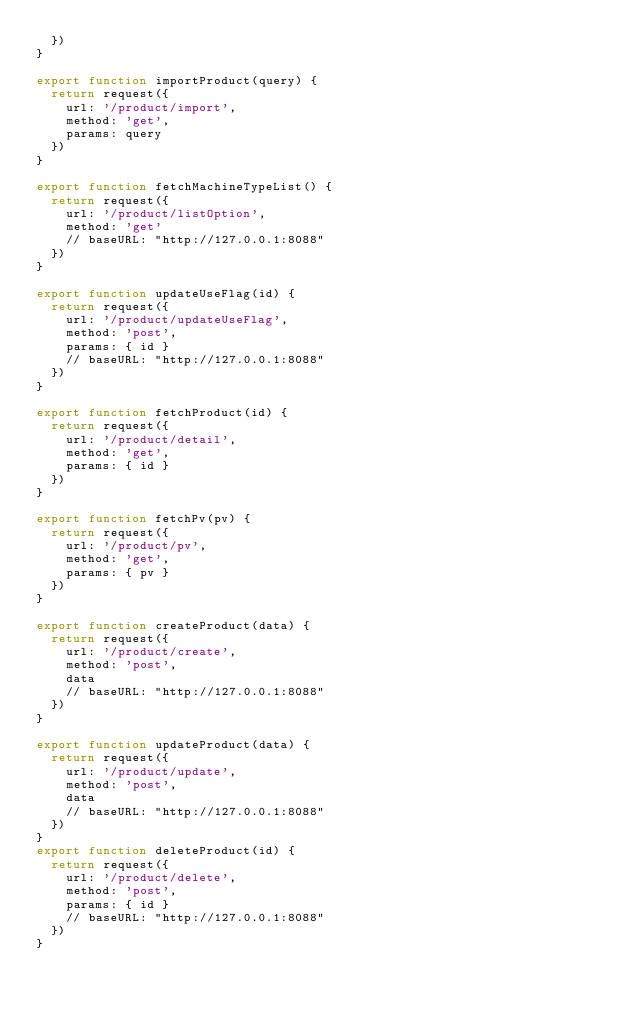<code> <loc_0><loc_0><loc_500><loc_500><_JavaScript_>  })
}

export function importProduct(query) {
  return request({
    url: '/product/import',
    method: 'get',
    params: query
  })
}

export function fetchMachineTypeList() {
  return request({
    url: '/product/listOption',
    method: 'get'
    // baseURL: "http://127.0.0.1:8088"
  })
}

export function updateUseFlag(id) {
  return request({
    url: '/product/updateUseFlag',
    method: 'post',
    params: { id }
    // baseURL: "http://127.0.0.1:8088"
  })
}

export function fetchProduct(id) {
  return request({
    url: '/product/detail',
    method: 'get',
    params: { id }
  })
}

export function fetchPv(pv) {
  return request({
    url: '/product/pv',
    method: 'get',
    params: { pv }
  })
}

export function createProduct(data) {
  return request({
    url: '/product/create',
    method: 'post',
    data
    // baseURL: "http://127.0.0.1:8088"
  })
}

export function updateProduct(data) {
  return request({
    url: '/product/update',
    method: 'post',
    data
    // baseURL: "http://127.0.0.1:8088"
  })
}
export function deleteProduct(id) {
  return request({
    url: '/product/delete',
    method: 'post',
    params: { id }
    // baseURL: "http://127.0.0.1:8088"
  })
}
</code> 